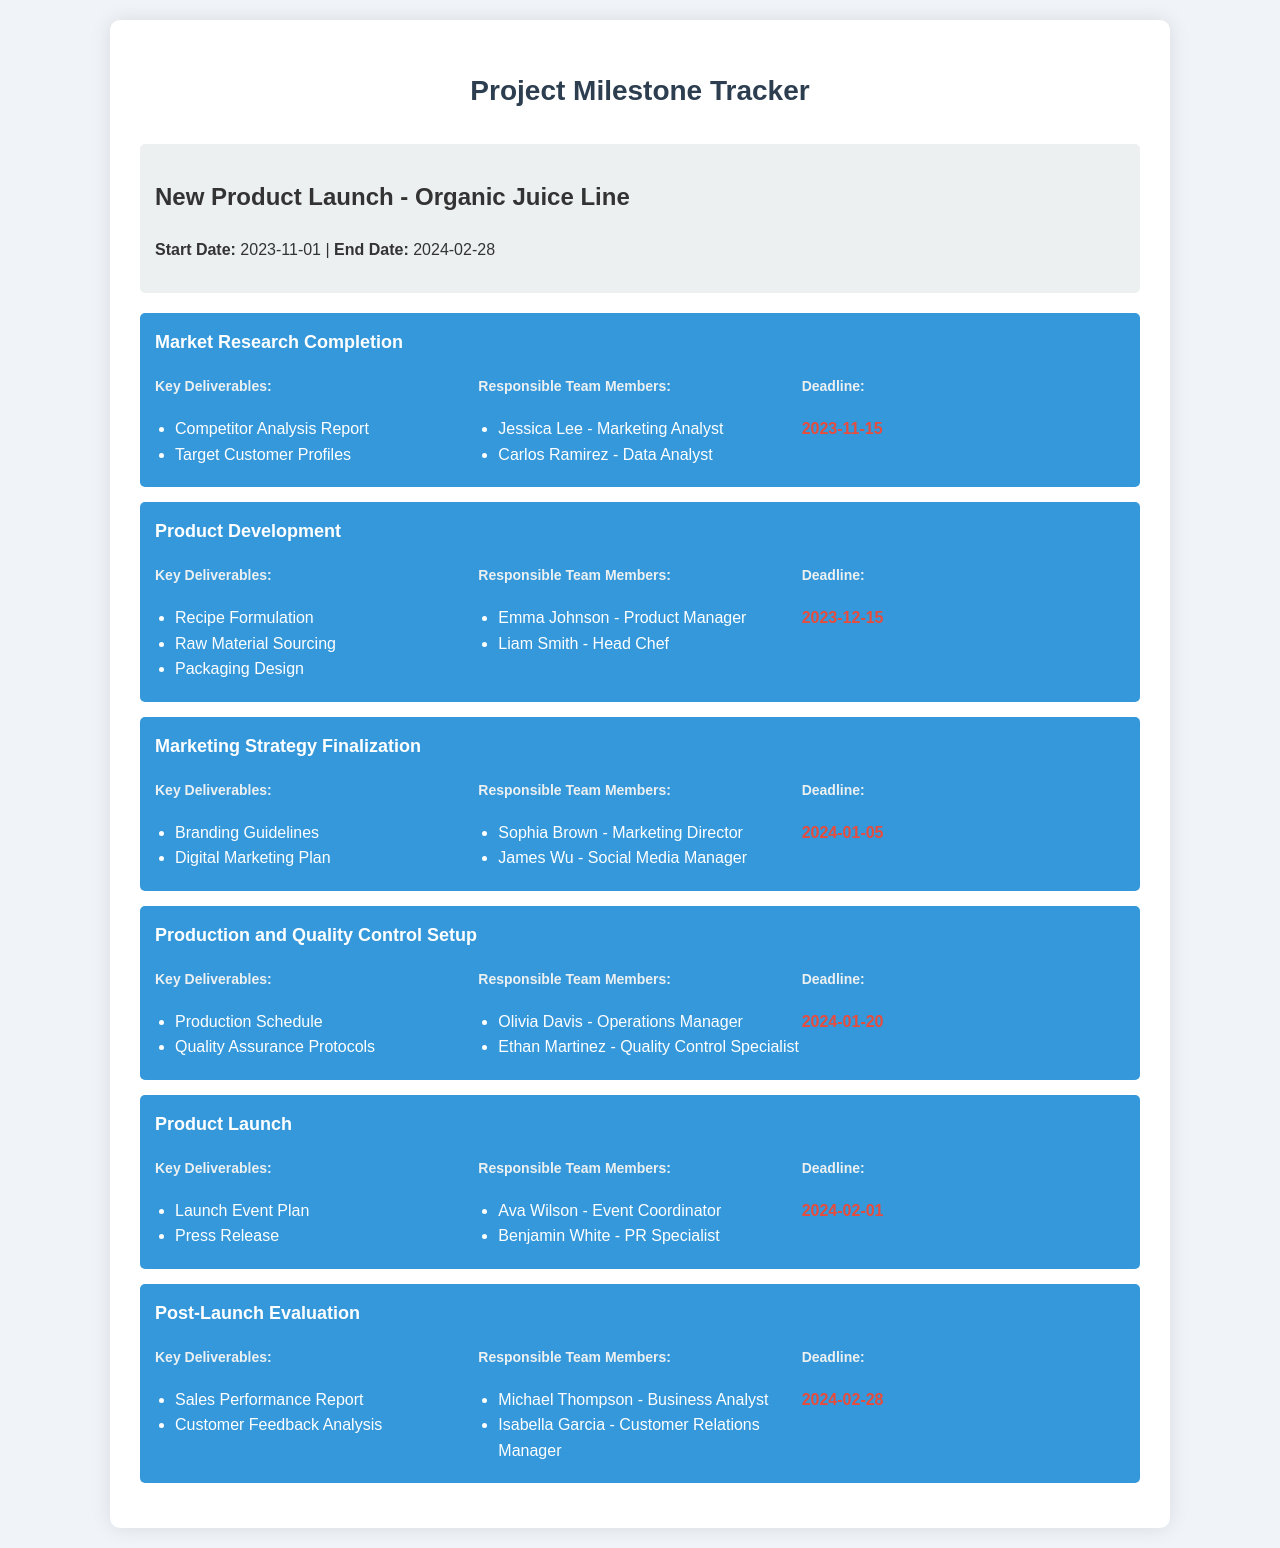What is the start date of the project? The start date of the project is mentioned in the project info section.
Answer: 2023-11-01 Who are the responsible team members for the Market Research Completion milestone? The responsible team members for this milestone are listed under the respective milestone section.
Answer: Jessica Lee, Carlos Ramirez What is the deadline for the Product Development milestone? The deadline for this milestone is specified in its milestone section.
Answer: 2023-12-15 What key deliverable is due on 2024-01-20? The key deliverables are listed under each milestone and the one due on this date is specified in the details.
Answer: Production Schedule, Quality Assurance Protocols Which milestone has the latest deadline? The latest milestone deadline can be identified by looking at all the milestones' deadlines.
Answer: 2024-02-28 Who is responsible for the Post-Launch Evaluation? The responsible team members for this milestone are mentioned under its details.
Answer: Michael Thompson, Isabella Garcia What is the title of the first milestone? The titles of the milestones are provided at the beginning of each milestone section.
Answer: Market Research Completion How many milestones are listed in total? The number of milestones can be counted from the milestones section.
Answer: 6 